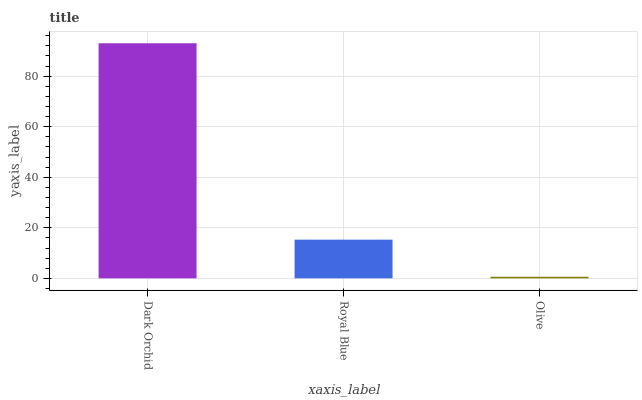Is Olive the minimum?
Answer yes or no. Yes. Is Dark Orchid the maximum?
Answer yes or no. Yes. Is Royal Blue the minimum?
Answer yes or no. No. Is Royal Blue the maximum?
Answer yes or no. No. Is Dark Orchid greater than Royal Blue?
Answer yes or no. Yes. Is Royal Blue less than Dark Orchid?
Answer yes or no. Yes. Is Royal Blue greater than Dark Orchid?
Answer yes or no. No. Is Dark Orchid less than Royal Blue?
Answer yes or no. No. Is Royal Blue the high median?
Answer yes or no. Yes. Is Royal Blue the low median?
Answer yes or no. Yes. Is Olive the high median?
Answer yes or no. No. Is Olive the low median?
Answer yes or no. No. 